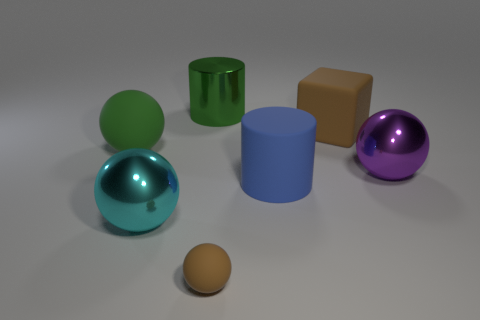Is the number of metal cylinders right of the tiny brown object the same as the number of large purple metallic spheres?
Your answer should be very brief. No. What number of blue cylinders are made of the same material as the green ball?
Your answer should be compact. 1. There is a small thing that is made of the same material as the brown block; what is its color?
Keep it short and to the point. Brown. Is the size of the brown rubber cube the same as the ball that is behind the big purple shiny sphere?
Your answer should be very brief. Yes. What is the shape of the blue thing?
Ensure brevity in your answer.  Cylinder. How many other things have the same color as the small thing?
Your answer should be compact. 1. There is a big rubber object that is the same shape as the tiny thing; what is its color?
Your answer should be very brief. Green. How many rubber objects are on the left side of the matte sphere right of the green matte thing?
Offer a very short reply. 1. What number of cubes are big objects or tiny purple rubber things?
Provide a succinct answer. 1. Are there any big purple shiny things?
Your response must be concise. Yes. 